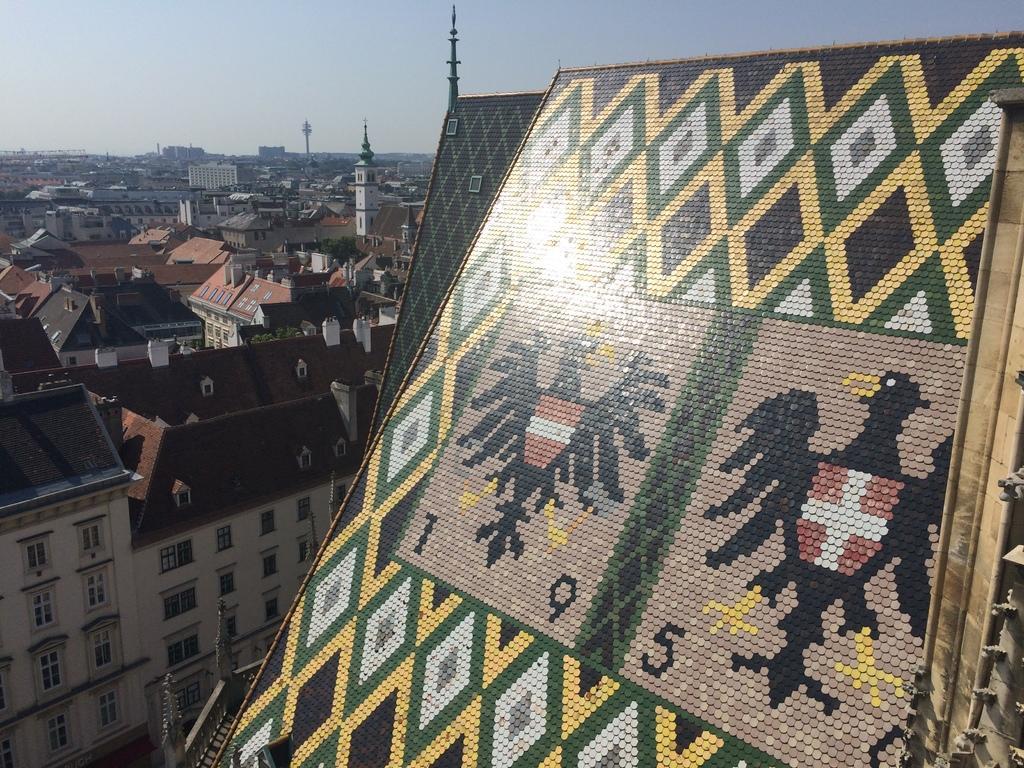Could you give a brief overview of what you see in this image? In this image, on the right there is a roof with designs on it. On the left there are buildings, towers, windows, railing, sky. 